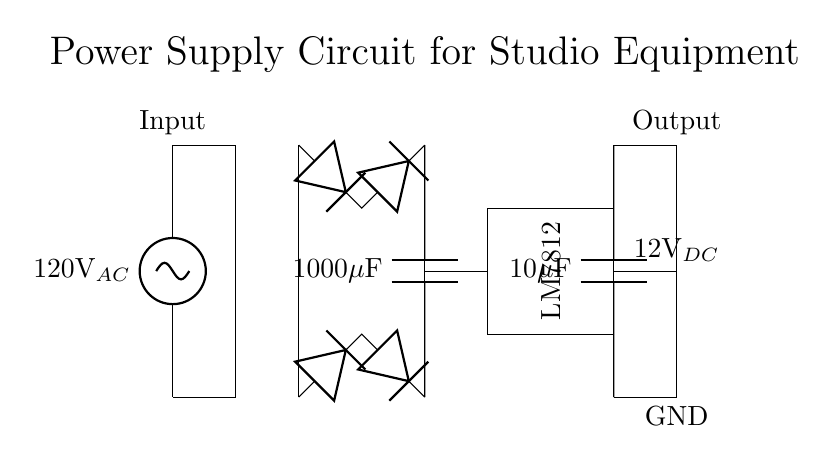What is the AC input voltage? The AC input voltage is displayed at the left side of the circuit, indicating 120 volts.
Answer: 120 volts What component converts AC to DC? The component that converts AC (alternating current) to DC (direct current) in the circuit is the rectifier bridge, which consists of diodes.
Answer: Rectifier Bridge What is the value of the smoothing capacitor? The smoothing capacitor is labeled directly in the circuit diagram as having a value of 1000 microfarads.
Answer: 1000 microfarads What is the output voltage of the voltage regulator? The voltage regulator, identified as LM7812, outputs a regulated voltage of 12 volts as indicated in the diagram.
Answer: 12 volts How many diodes are in the rectifier bridge? The rectifier bridge consists of four diodes arranged to allow current to flow in a single direction, resulting in DC output.
Answer: Four What is the purpose of the output capacitor? The output capacitor's purpose is to filter the output voltage, ensuring smooth operation of the powered studio equipment.
Answer: To filter voltage Why is voltage regulation important in this circuit? Voltage regulation is crucial as it maintains a consistent output voltage for studio equipment, protecting against voltage fluctuations that could damage sensitive devices.
Answer: Consistent output voltage 